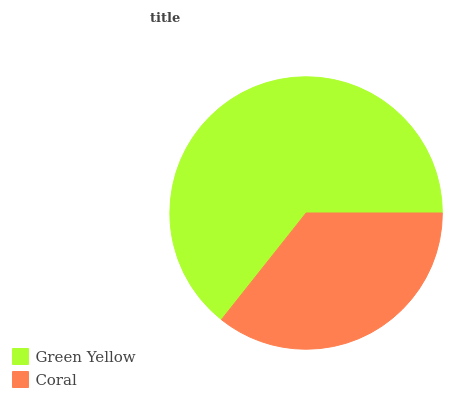Is Coral the minimum?
Answer yes or no. Yes. Is Green Yellow the maximum?
Answer yes or no. Yes. Is Coral the maximum?
Answer yes or no. No. Is Green Yellow greater than Coral?
Answer yes or no. Yes. Is Coral less than Green Yellow?
Answer yes or no. Yes. Is Coral greater than Green Yellow?
Answer yes or no. No. Is Green Yellow less than Coral?
Answer yes or no. No. Is Green Yellow the high median?
Answer yes or no. Yes. Is Coral the low median?
Answer yes or no. Yes. Is Coral the high median?
Answer yes or no. No. Is Green Yellow the low median?
Answer yes or no. No. 